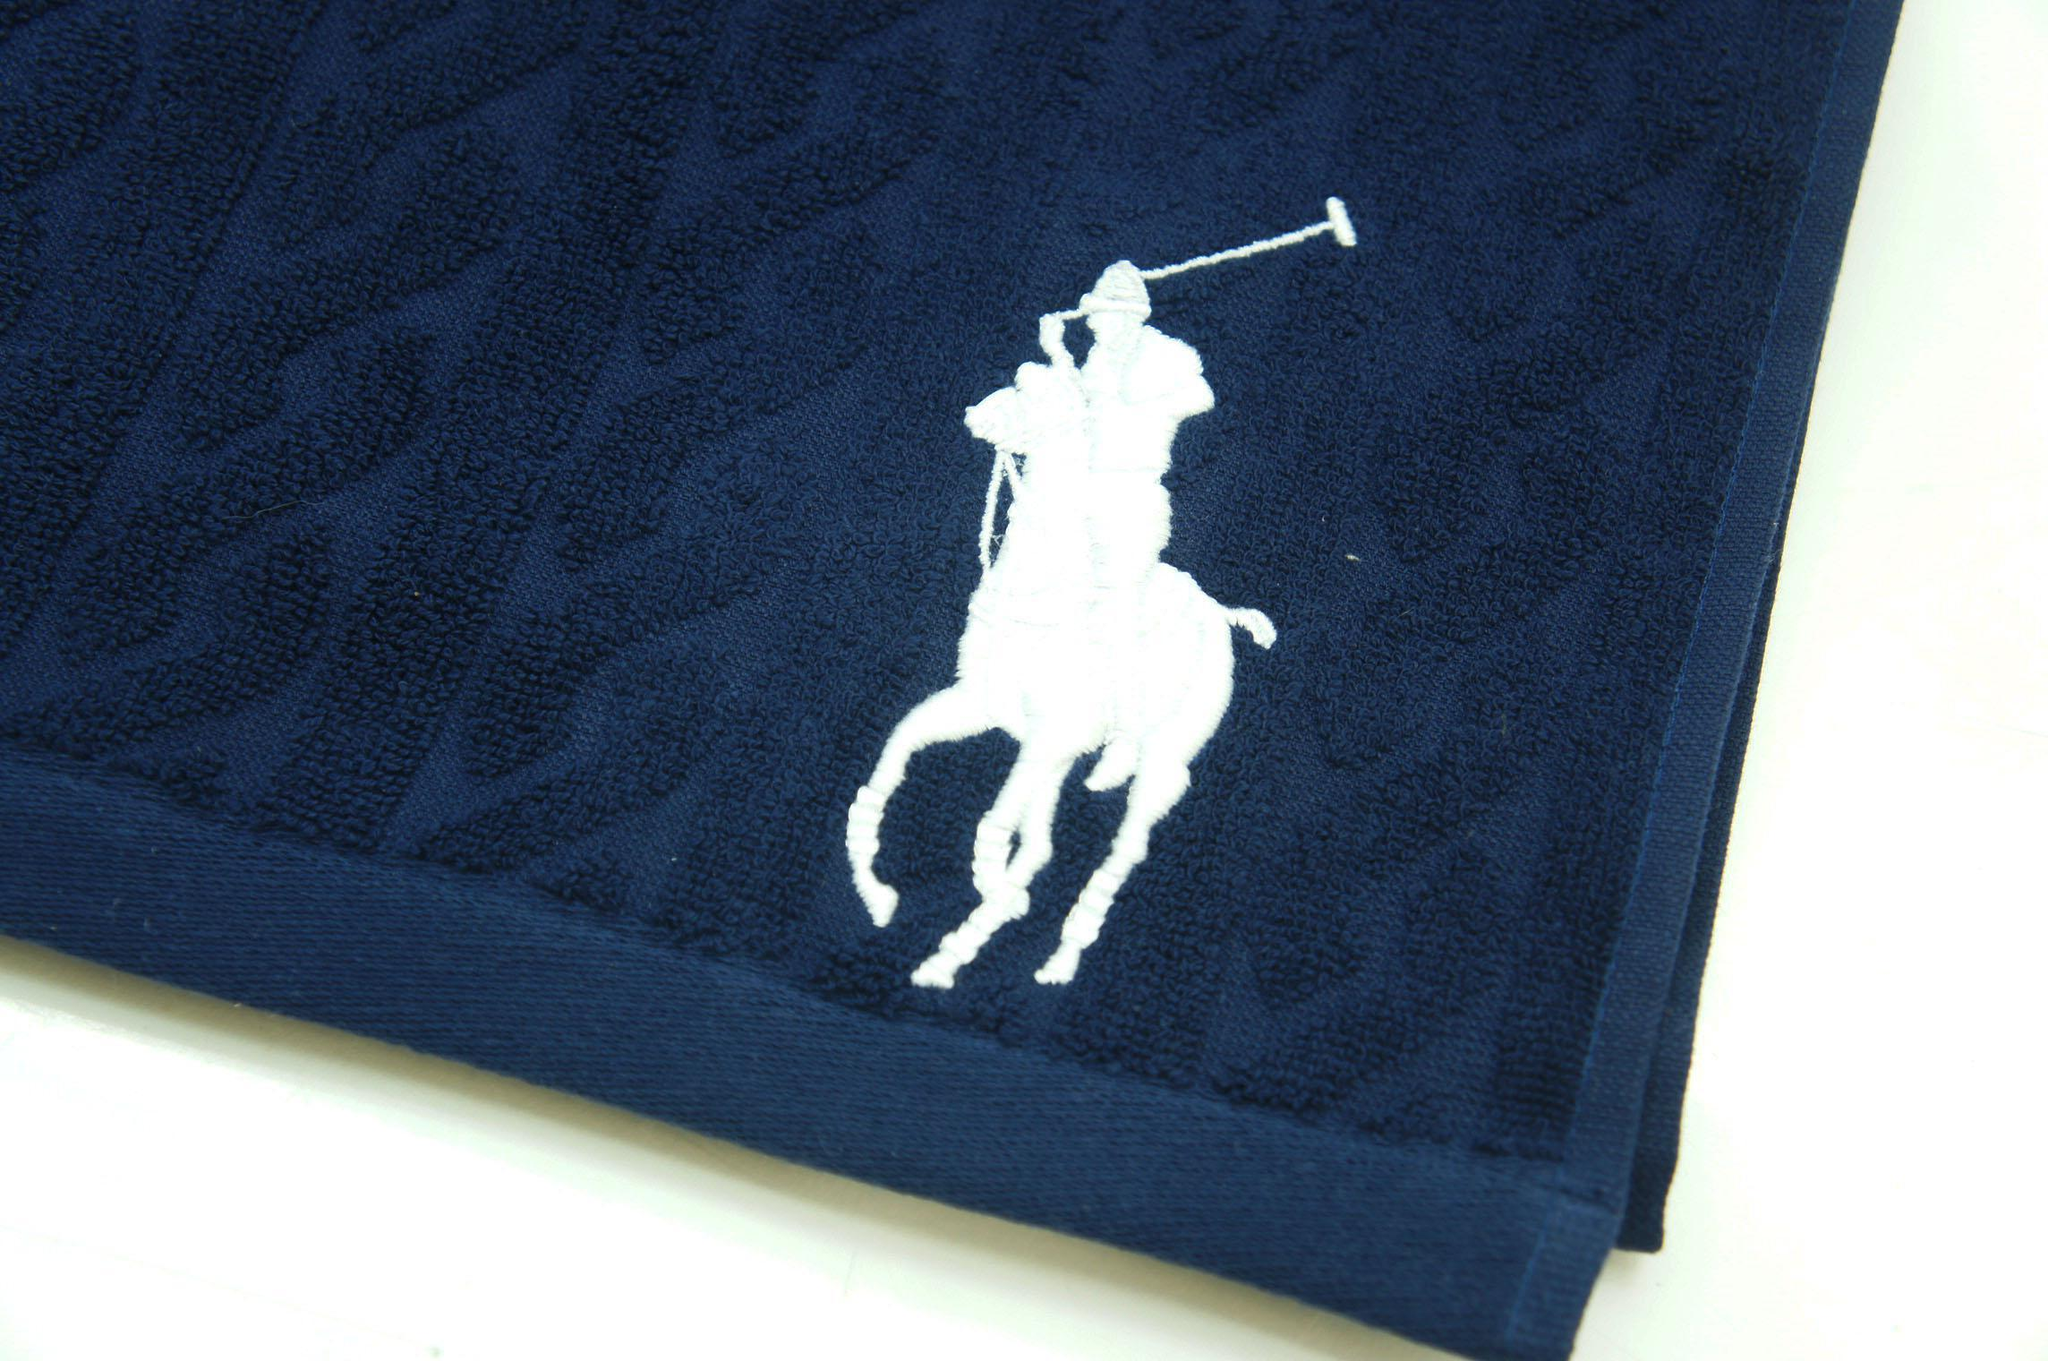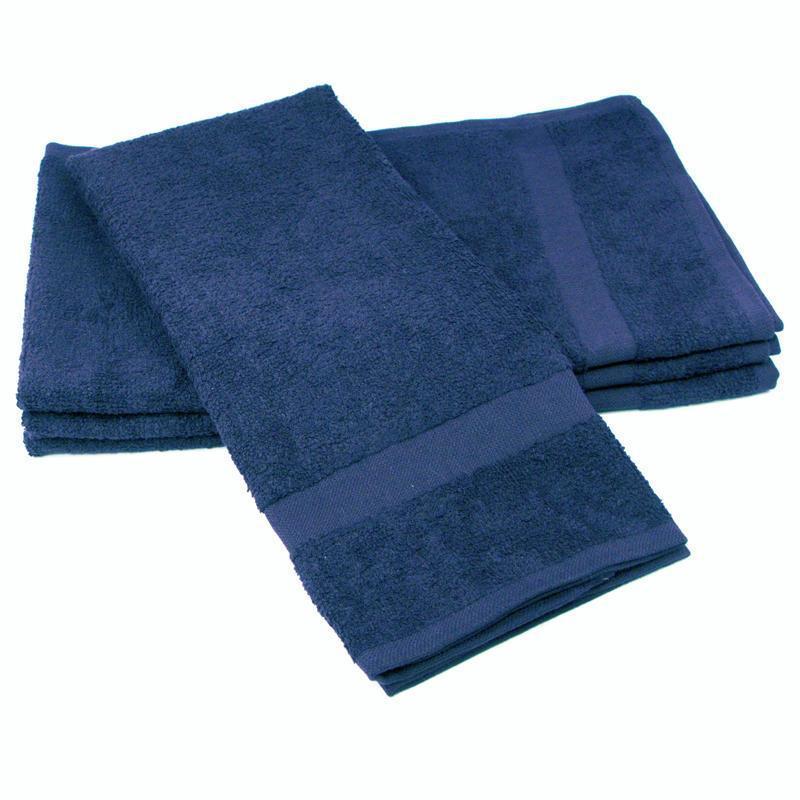The first image is the image on the left, the second image is the image on the right. Evaluate the accuracy of this statement regarding the images: "The right image contains only white towels, while the left image has at least one blue towel.". Is it true? Answer yes or no. No. 